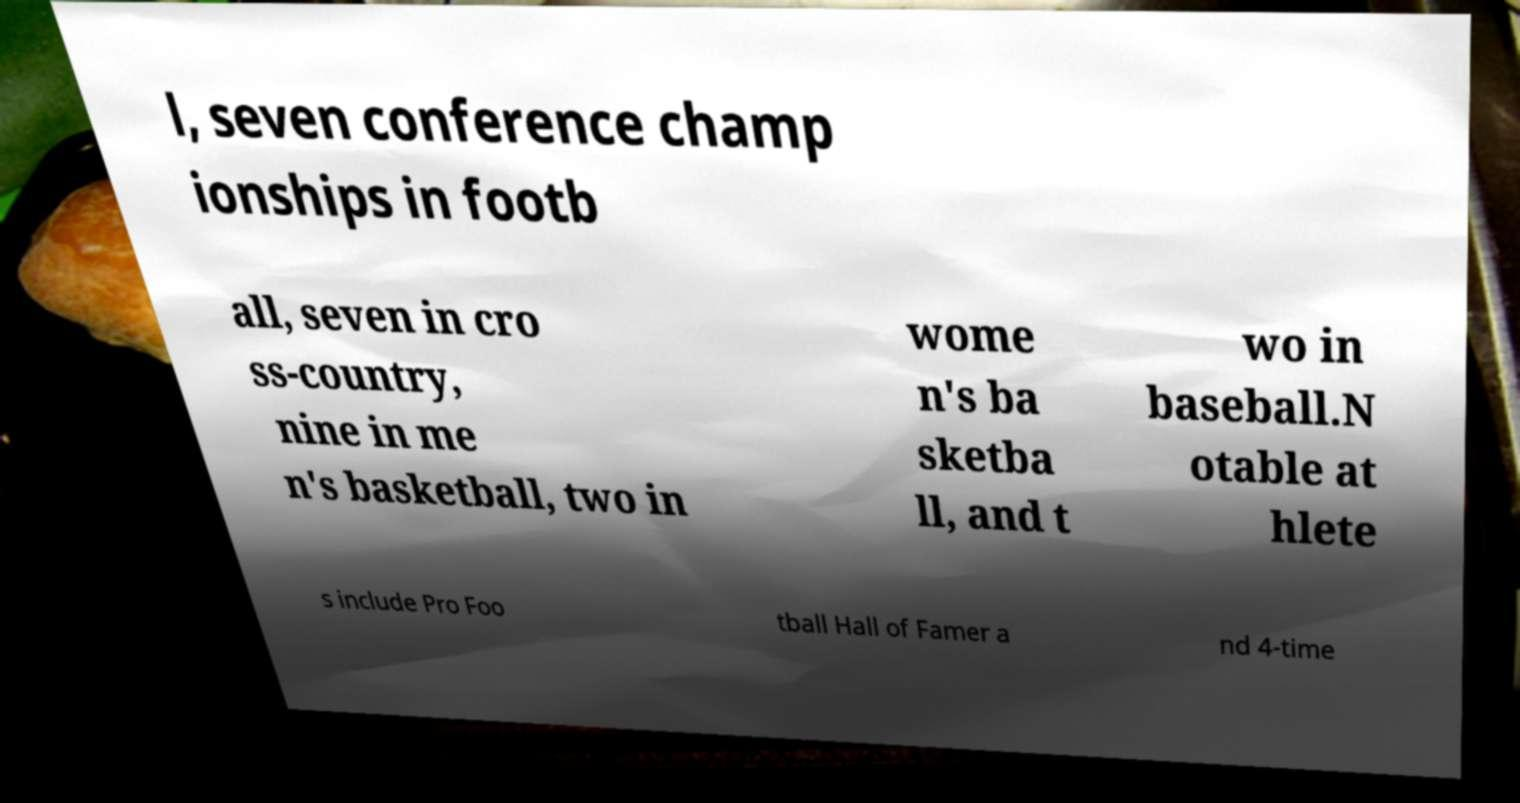Can you accurately transcribe the text from the provided image for me? l, seven conference champ ionships in footb all, seven in cro ss-country, nine in me n's basketball, two in wome n's ba sketba ll, and t wo in baseball.N otable at hlete s include Pro Foo tball Hall of Famer a nd 4-time 